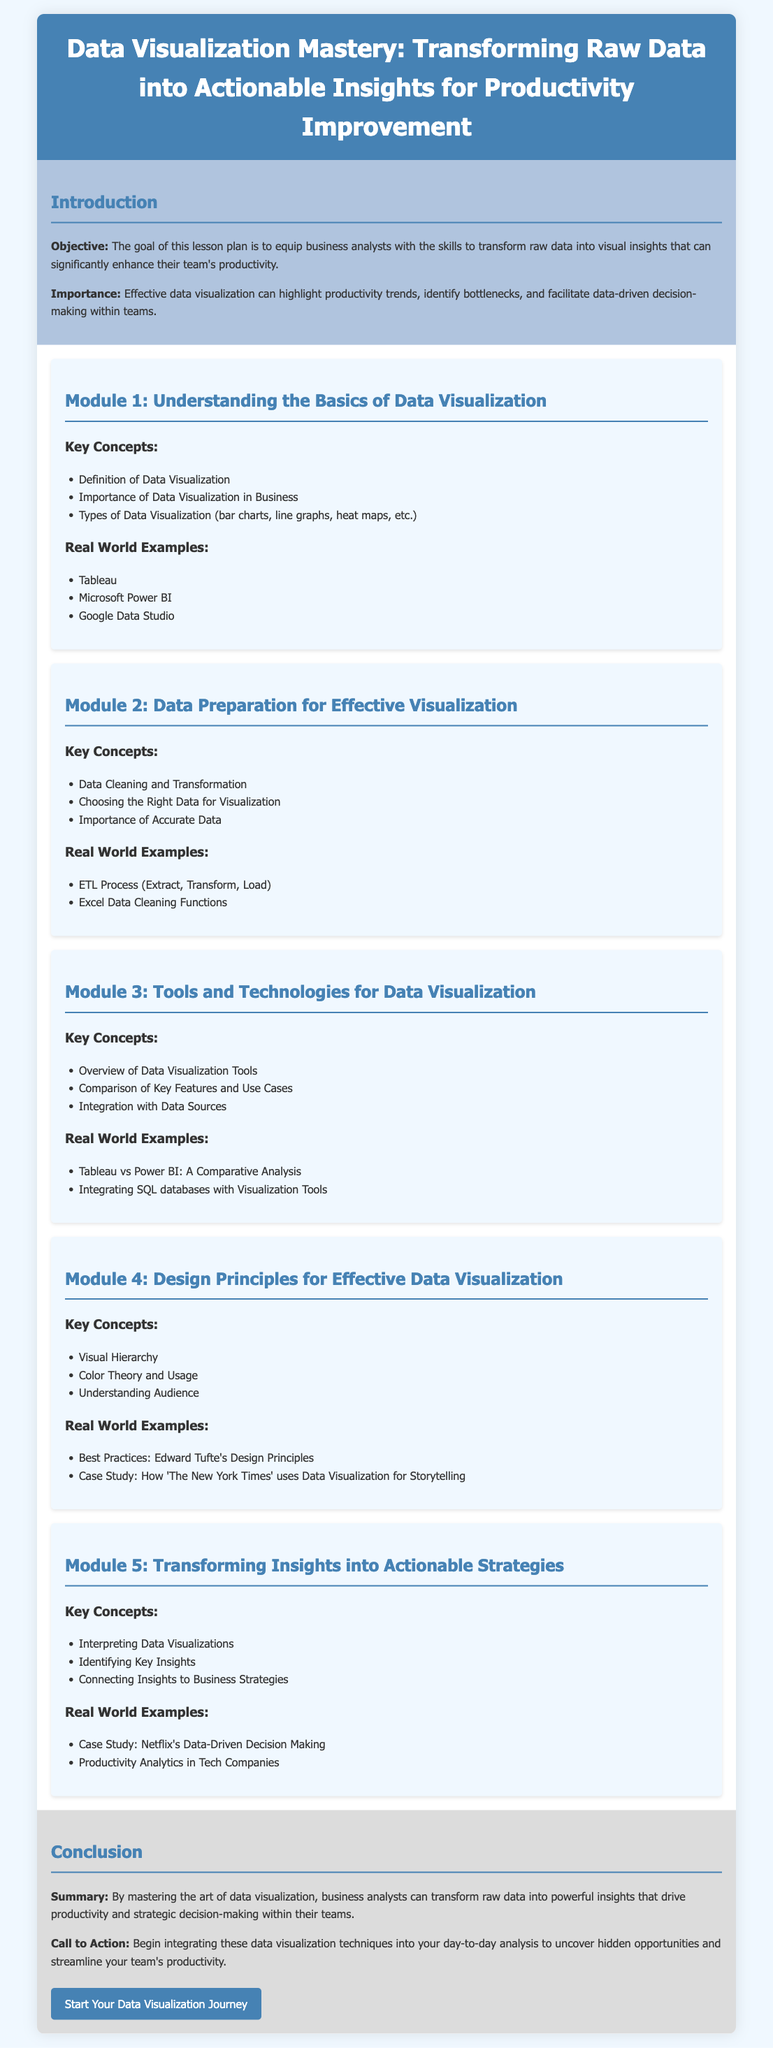What is the objective of the lesson plan? The objective is to equip business analysts with the skills to transform raw data into visual insights that can significantly enhance their team's productivity.
Answer: Equip business analysts with skills What are the types of data visualization mentioned? The document lists types of data visualization, such as bar charts, line graphs, heat maps, etc.
Answer: Bar charts, line graphs, heat maps What is the importance of data visualization highlighted in the introduction? The importance is that effective data visualization can highlight productivity trends, identify bottlenecks, and facilitate data-driven decision-making.
Answer: Highlight productivity trends Which module focuses on design principles? The module that focuses on design principles is Module 4.
Answer: Module 4 Name one real-world example mentioned for tools in data visualization. The document provides real-world examples such as Tableau, Microsoft Power BI, and Google Data Studio.
Answer: Tableau What is a key concept in Module 5? A key concept in Module 5 is interpreting data visualizations.
Answer: Interpreting data visualizations Which case study is mentioned in relation to data-driven decision-making? The case study mentioned is on Netflix's data-driven decision making.
Answer: Netflix What is emphasized in the conclusion regarding skills in data visualization? The conclusion emphasizes that mastering data visualization drives productivity and strategic decision-making.
Answer: Drives productivity and strategic decision-making 